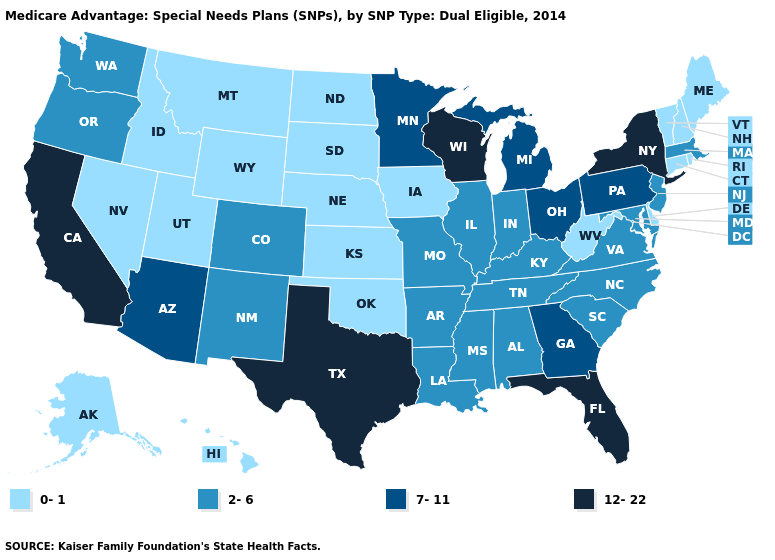What is the highest value in states that border Kansas?
Answer briefly. 2-6. Name the states that have a value in the range 7-11?
Concise answer only. Arizona, Georgia, Michigan, Minnesota, Ohio, Pennsylvania. What is the lowest value in the USA?
Quick response, please. 0-1. Which states hav the highest value in the MidWest?
Answer briefly. Wisconsin. Does South Carolina have a higher value than New Jersey?
Answer briefly. No. Name the states that have a value in the range 12-22?
Write a very short answer. California, Florida, New York, Texas, Wisconsin. Does the map have missing data?
Give a very brief answer. No. Which states hav the highest value in the West?
Short answer required. California. What is the highest value in the USA?
Give a very brief answer. 12-22. Does Connecticut have the same value as Michigan?
Be succinct. No. What is the value of South Dakota?
Answer briefly. 0-1. Name the states that have a value in the range 12-22?
Write a very short answer. California, Florida, New York, Texas, Wisconsin. Does Montana have a higher value than Texas?
Concise answer only. No. What is the value of Kansas?
Give a very brief answer. 0-1. What is the value of West Virginia?
Short answer required. 0-1. 